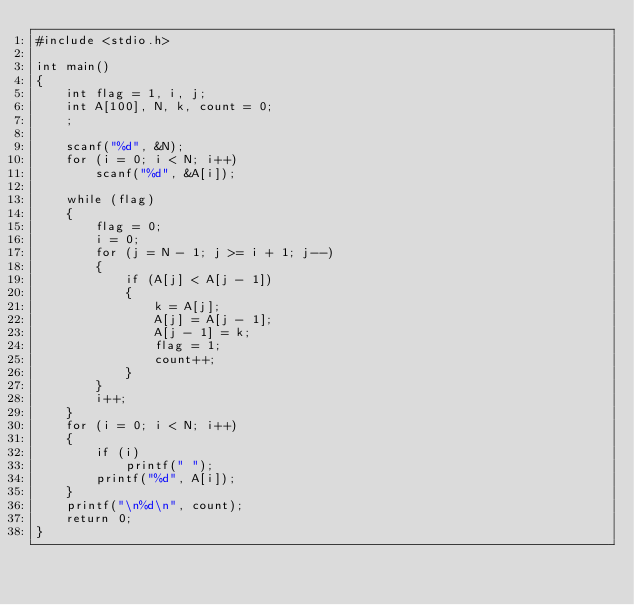<code> <loc_0><loc_0><loc_500><loc_500><_C_>#include <stdio.h>

int main()
{
    int flag = 1, i, j;
    int A[100], N, k, count = 0;
    ;

    scanf("%d", &N);
    for (i = 0; i < N; i++)
        scanf("%d", &A[i]);

    while (flag)
    {
        flag = 0;
        i = 0;
        for (j = N - 1; j >= i + 1; j--)
        {
            if (A[j] < A[j - 1])
            {
                k = A[j];
                A[j] = A[j - 1];
                A[j - 1] = k;
                flag = 1;
                count++;
            }
        }
        i++;
    }
    for (i = 0; i < N; i++)
    {
        if (i)
            printf(" ");
        printf("%d", A[i]);
    }
    printf("\n%d\n", count);
    return 0;
}
</code> 